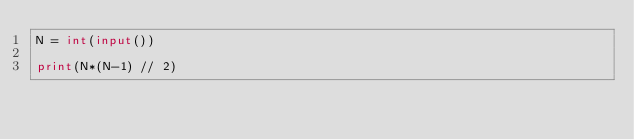Convert code to text. <code><loc_0><loc_0><loc_500><loc_500><_Python_>N = int(input())

print(N*(N-1) // 2)</code> 